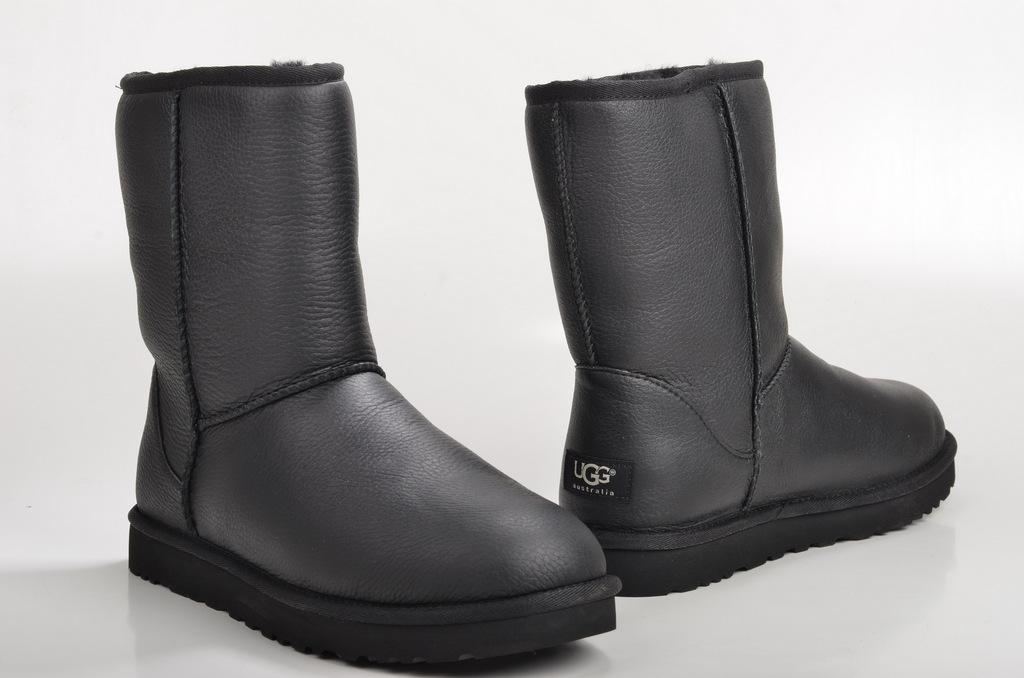What type of footwear is visible in the image? There is a pair of shoes in the image. What is the color of the surface on which the shoes are placed? The shoes are on a white surface. What type of pancake is being served on the shoes in the image? There is no pancake present in the image, and the shoes are not serving any food. 